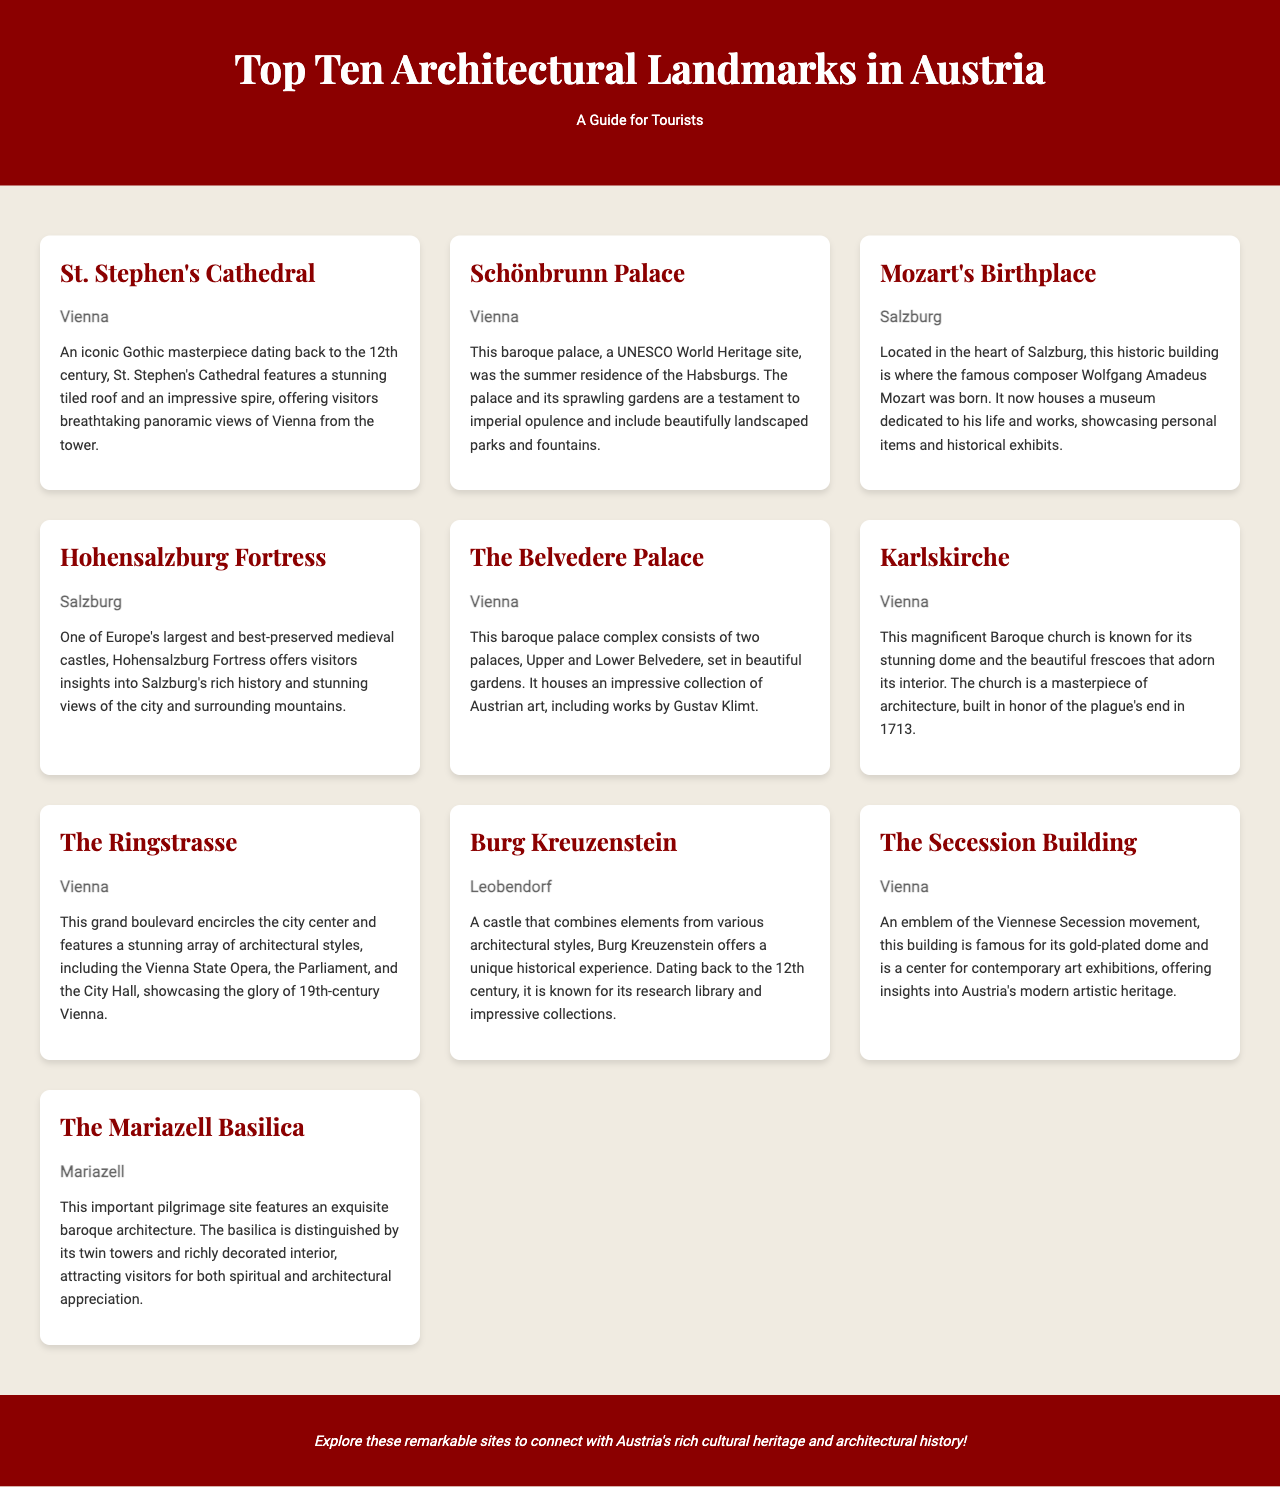What is the architectural style of St. Stephen's Cathedral? The architectural style of St. Stephen's Cathedral is Gothic, as mentioned in the description.
Answer: Gothic Where is Schönbrunn Palace located? The location of Schönbrunn Palace is given as Vienna in the document.
Answer: Vienna Which famous composer was born in Mozart's Birthplace? The document states that Wolfgang Amadeus Mozart was born in Mozart's Birthplace.
Answer: Wolfgang Amadeus Mozart What year was the Karlskirche built in honor of the plague's end? The document indicates that the Karlskirche was built in 1713, during a time of crisis.
Answer: 1713 What significant collection does The Belvedere Palace house? The Belvedere Palace is noted in the document to house an impressive collection of Austrian art.
Answer: Austrian art Which landmark offers panoramic views of Vienna from its tower? The landmark known for offering panoramic views of Vienna is St. Stephen's Cathedral, as described in the brochure.
Answer: St. Stephen's Cathedral What is the main theme represented by The Secession Building? The main theme represented by The Secession Building is the Viennese Secession movement, as stated in the text.
Answer: Viennese Secession movement How many palaces make up The Belvedere Palace complex? The document mentions that The Belvedere Palace complex consists of two palaces.
Answer: Two What is the primary purpose of the Mariazell Basilica? The primary purpose of the Mariazell Basilica, as noted in the document, is as an important pilgrimage site.
Answer: Pilgrimage site What type of exhibitions does The Secession Building host? The Seceession Building is described as hosting contemporary art exhibitions, according to the brochure.
Answer: Contemporary art exhibitions 